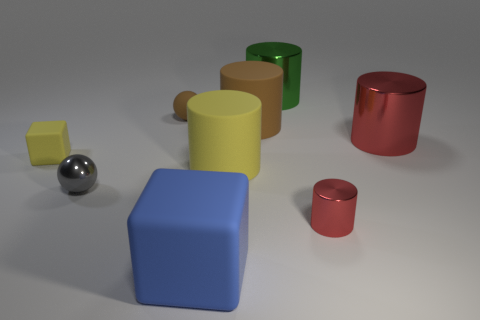Subtract all yellow balls. How many red cylinders are left? 2 Subtract 3 cylinders. How many cylinders are left? 2 Add 1 tiny metal things. How many objects exist? 10 Subtract all red cylinders. How many cylinders are left? 3 Subtract all tiny cylinders. How many cylinders are left? 4 Subtract all cubes. How many objects are left? 7 Subtract all purple cylinders. Subtract all yellow cubes. How many cylinders are left? 5 Subtract all small yellow blocks. Subtract all big yellow matte things. How many objects are left? 7 Add 1 cubes. How many cubes are left? 3 Add 9 large green spheres. How many large green spheres exist? 9 